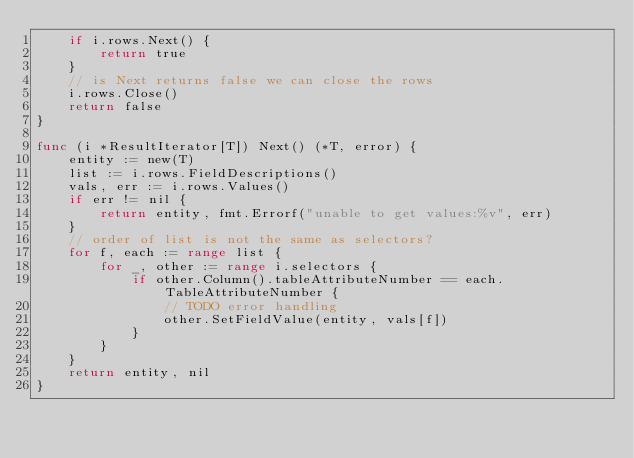Convert code to text. <code><loc_0><loc_0><loc_500><loc_500><_Go_>	if i.rows.Next() {
		return true
	}
	// is Next returns false we can close the rows
	i.rows.Close()
	return false
}

func (i *ResultIterator[T]) Next() (*T, error) {
	entity := new(T)
	list := i.rows.FieldDescriptions()
	vals, err := i.rows.Values()
	if err != nil {
		return entity, fmt.Errorf("unable to get values:%v", err)
	}
	// order of list is not the same as selectors?
	for f, each := range list {
		for _, other := range i.selectors {
			if other.Column().tableAttributeNumber == each.TableAttributeNumber {
				// TODO error handling
				other.SetFieldValue(entity, vals[f])
			}
		}
	}
	return entity, nil
}
</code> 